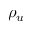<formula> <loc_0><loc_0><loc_500><loc_500>\rho _ { u }</formula> 